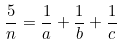<formula> <loc_0><loc_0><loc_500><loc_500>\frac { 5 } { n } = \frac { 1 } { a } + \frac { 1 } { b } + \frac { 1 } { c }</formula> 